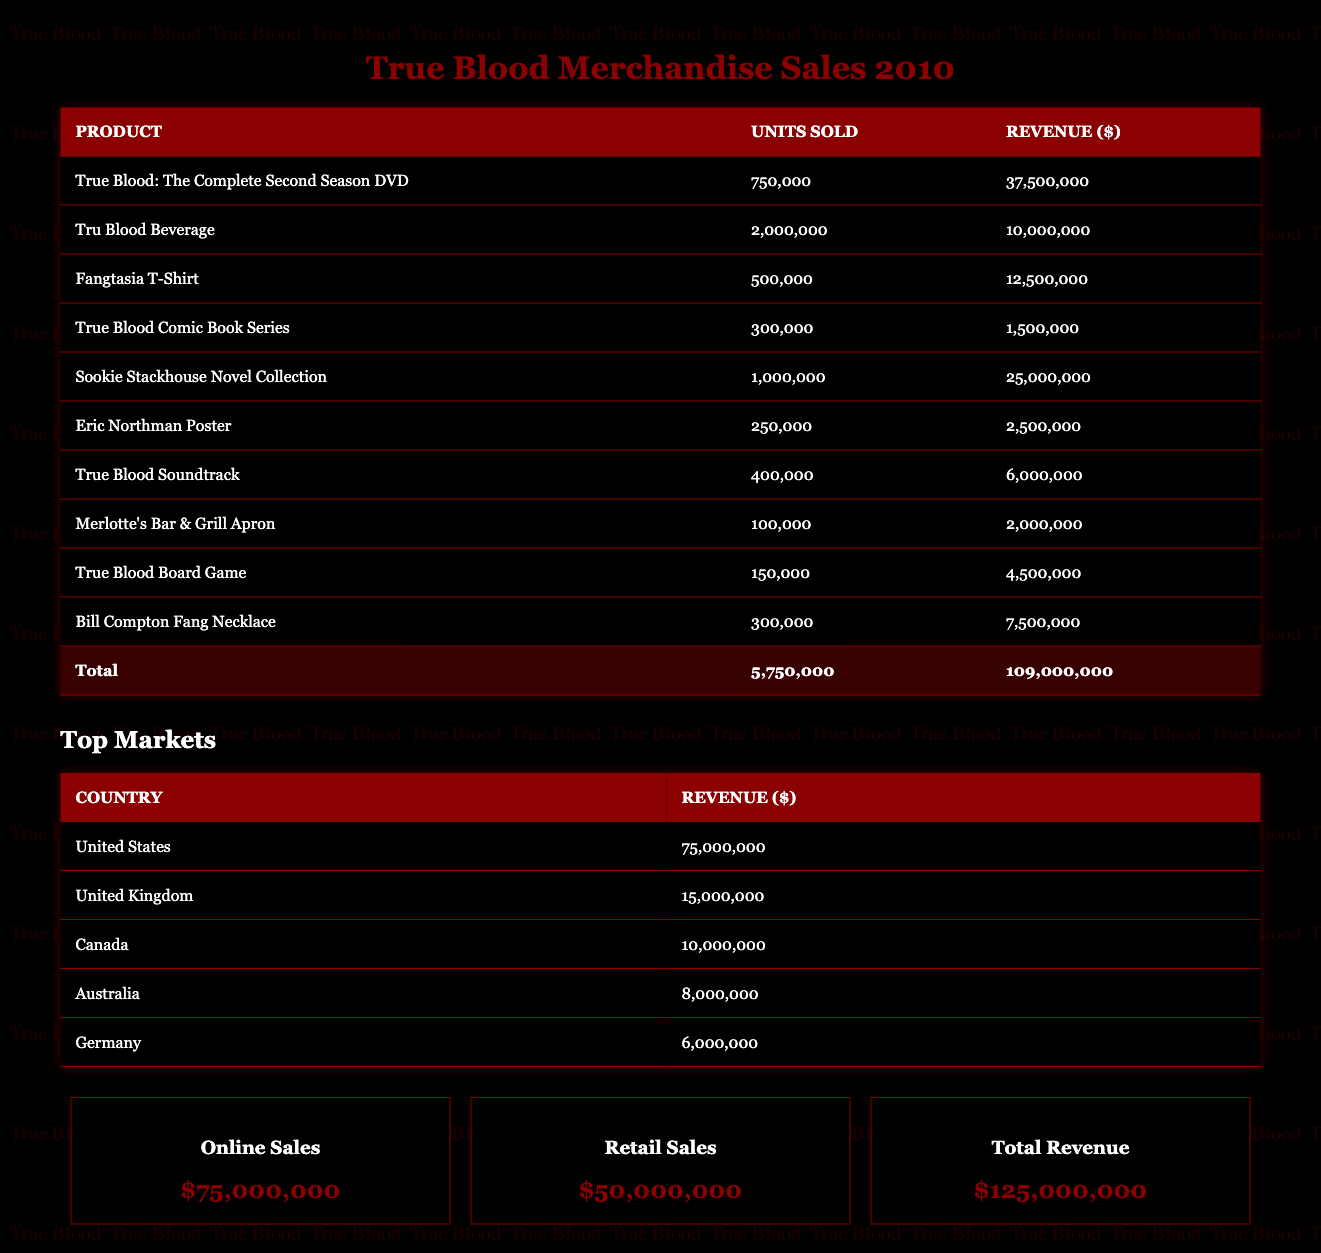What was the total revenue from merchandise sales in 2010? The total revenue from merchandise sales in 2010 is explicitly listed in the table as $125,000,000.
Answer: $125,000,000 Which product had the highest revenue in 2010? By looking at the revenue column, the product with the highest revenue is "True Blood: The Complete Second Season DVD" at $37,500,000.
Answer: True Blood: The Complete Second Season DVD How many units of the "Fangtasia T-Shirt" were sold? Referring to the units sold column, "Fangtasia T-Shirt" had 500,000 units sold.
Answer: 500,000 What is the total revenue generated from online sales? The table explicitly states that online sales generated $75,000,000.
Answer: $75,000,000 What was the total revenue from the top three markets? The top three markets by revenue are United States ($75,000,000), United Kingdom ($15,000,000), and Canada ($10,000,000). Adding these gives a total revenue of $75,000,000 + $15,000,000 + $10,000,000 = $100,000,000.
Answer: $100,000,000 Did "Sookie Stackhouse Novel Collection" generate more revenue than "True Blood Comic Book Series"? "Sookie Stackhouse Novel Collection" generated $25,000,000 while "True Blood Comic Book Series" generated only $1,500,000; thus, Sookie Stackhouse did generate more revenue.
Answer: Yes What was the combined revenue from "Eric Northman Poster" and "True Blood Soundtrack"? The revenue for "Eric Northman Poster" is $2,500,000 and for "True Blood Soundtrack" is $6,000,000. Adding these amounts gives $2,500,000 + $6,000,000 = $8,500,000.
Answer: $8,500,000 Is the total number of units sold for all products greater than 6 million? The total units sold for all products is 5,750,000, which is less than 6 million.
Answer: No How much revenue does the "Tru Blood Beverage" generate compared to the total revenue? "Tru Blood Beverage" generates $10,000,000. To find the percentage of total revenue, we calculate ($10,000,000 / $125,000,000) * 100 = 8%.
Answer: 8% 